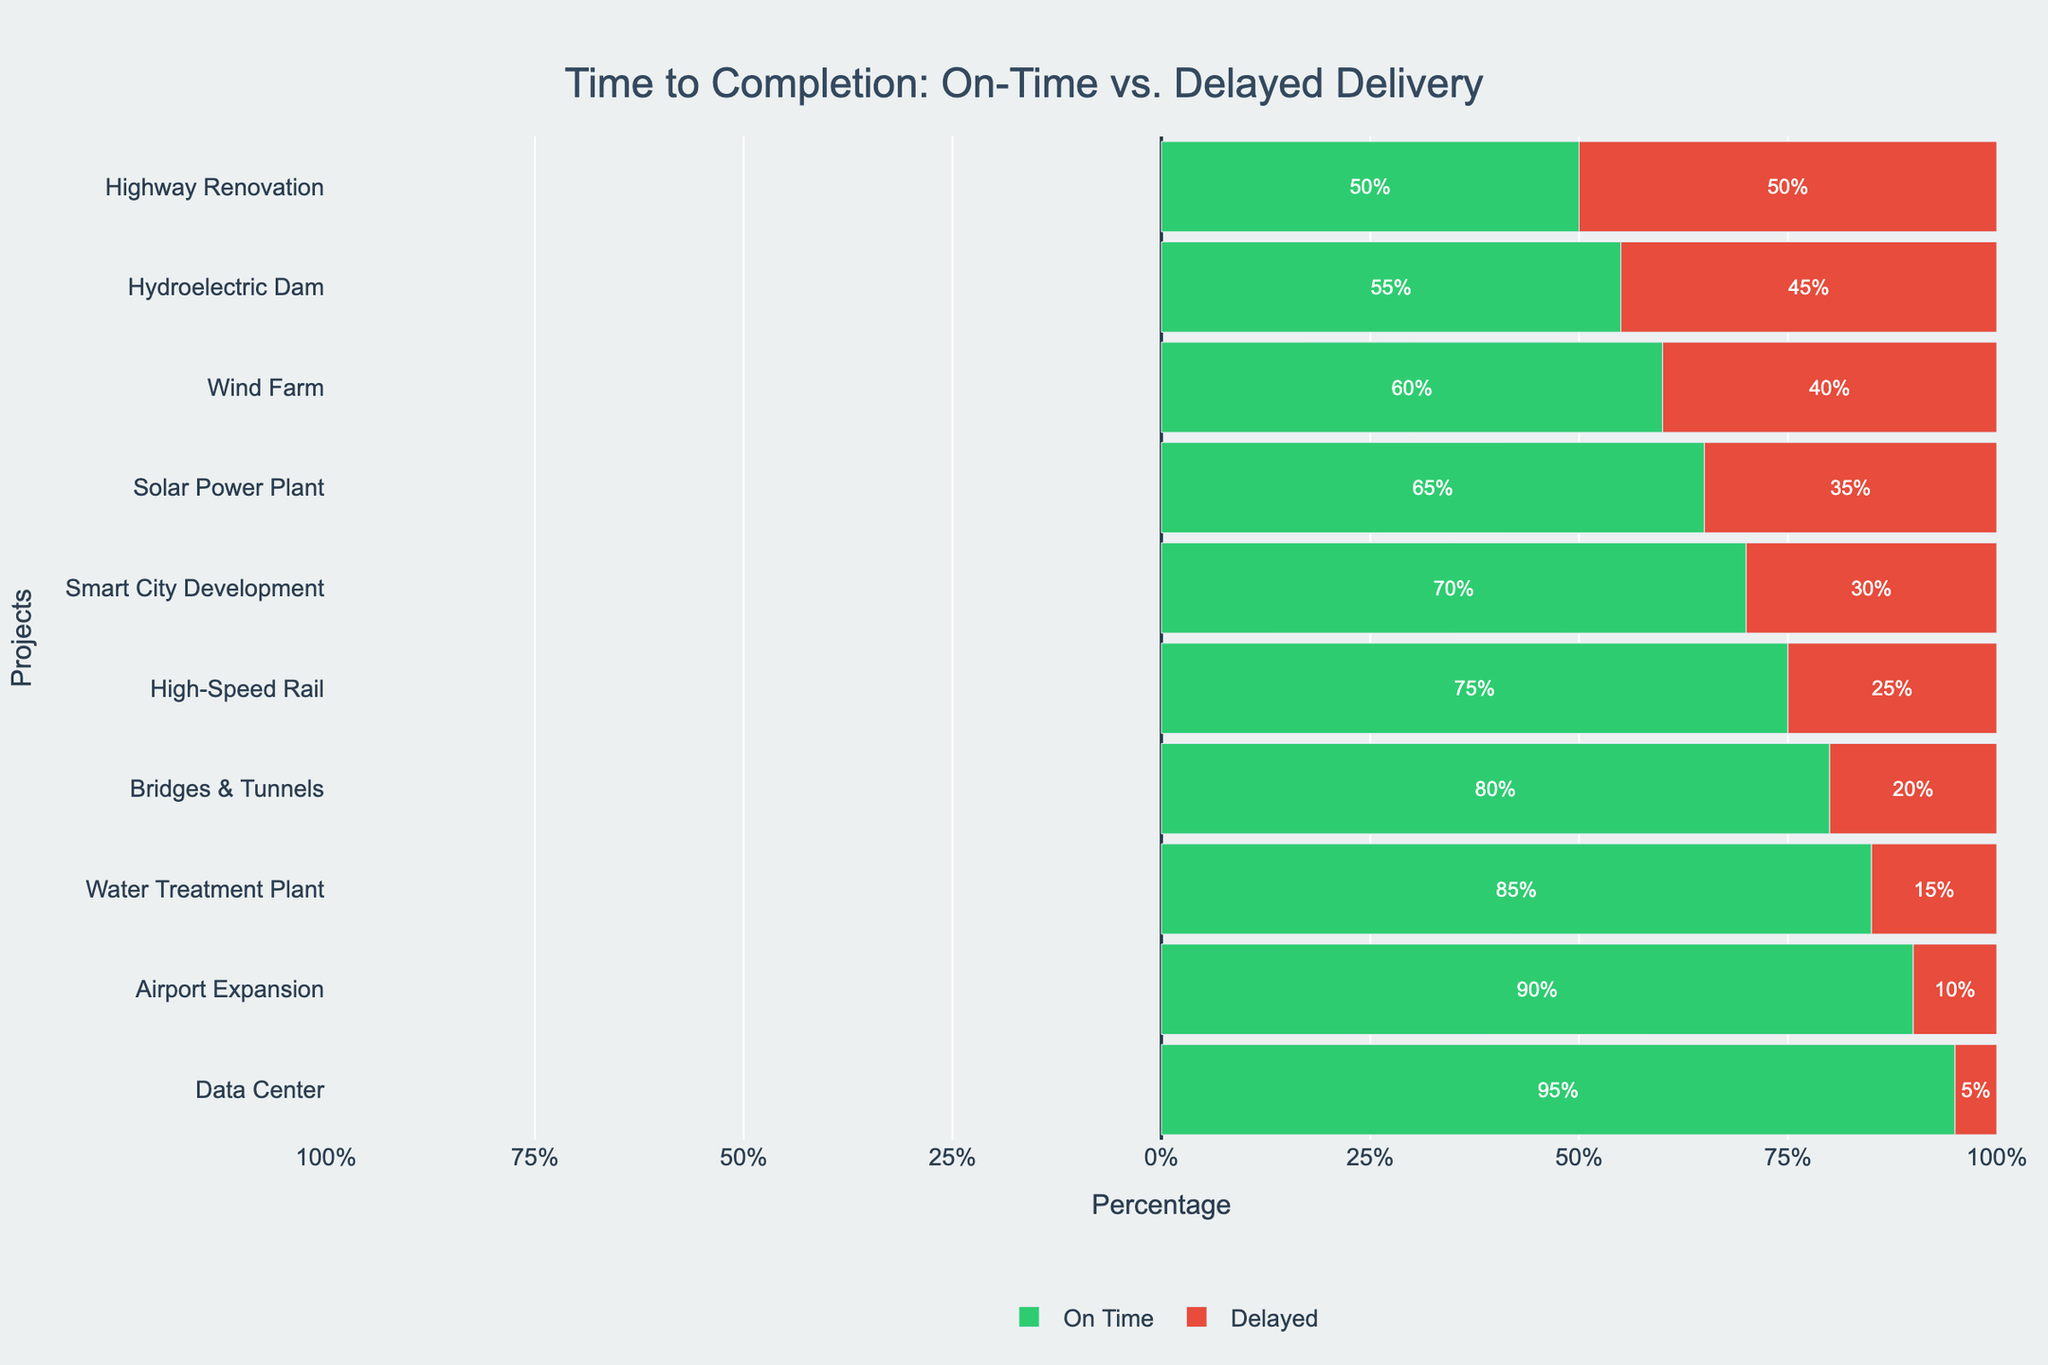Which project has the highest percentage of on-time delivery? To find the project with the highest on-time delivery percentage, look for the longest green bar or the highest percentage value in the "On Time" section.
Answer: Data Center Which engineering project has balanced on-time and delayed delivery? A balanced on-time and delayed delivery can be identified by finding the project where the green and red bars are of equal length, which corresponds to 50% each.
Answer: Highway Renovation What is the total percentage of delayed projects for WindWorks and GreenEnergy Constructors combined? Add the delayed percentages of WindWorks (40%) and GreenEnergy Constructors (45%) to find the total delayed percentage. 40% + 45% = 85%
Answer: 85% Compare the percentages of on-time delivery for Airport Expansion and Water Treatment Plant. Which one is higher and by how much? Observe and compare the green bars for the Airport Expansion and Water Treatment Plant; Airport Expansion (90%) and Water Treatment Plant (85%) show that Airport Expansion has a higher on-time percentage by 5%. 90% - 85% = 5%
Answer: Airport Expansion, by 5% How does the on-time delivery percentage for Smart City Development compare to ACME Engineering's High-Speed Rail project? Compare the green bars for Smart City Development (70%) and High-Speed Rail (75%); Smart City Development is lower by 5%. 75% - 70% = 5%
Answer: Lower by 5% What's the difference in delayed delivery percentage between TechStructures Ltd's Data Center and AeroBuild Corp's Airport Expansion? Subtract the delayed percentage for Airport Expansion (10%) from Data Center (5%). 10% - 5% = 5%
Answer: 5% Identify the project with the highest delayed delivery percentage and describe its on-time percentage. Find the project with the longest red bar; GreenEnergy Constructors’ Hydroelectric Dam has the highest delayed percentage (45%). Its on-time percentage is the smallest green bar remaining, which is 55%.
Answer: Hydroelectric Dam; On-Time: 55% What is the average on-time delivery percentage for the top three performing companies? Identify and sum the on-time percentages of the top three performing companies (Data Center: 95%, Airport Expansion: 90%, and Water Treatment Plant: 85%). Calculate the average: (95% + 90% + 85%) / 3 = 90%
Answer: 90% Which two projects have the most similar distribution of on-time versus delayed delivery percentages? Look for projects with similar lengths of green and red bars. Smart City Development (70-30) and Bridges & Tunnels (80-20) are not the most similar. Urban Innovations Inc. Smart City Development (70-30) closely matches ACME Engineering High-Speed Rail (75-25) in distribution.
Answer: Smart City Development and High-Speed Rail 